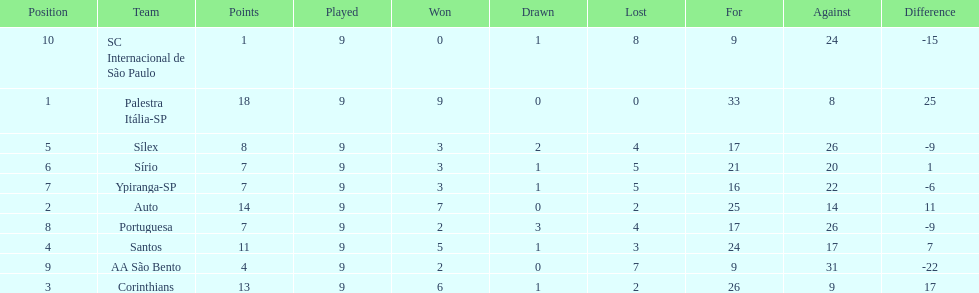In 1926 brazilian football,aside from the first place team, what other teams had winning records? Auto, Corinthians, Santos. 